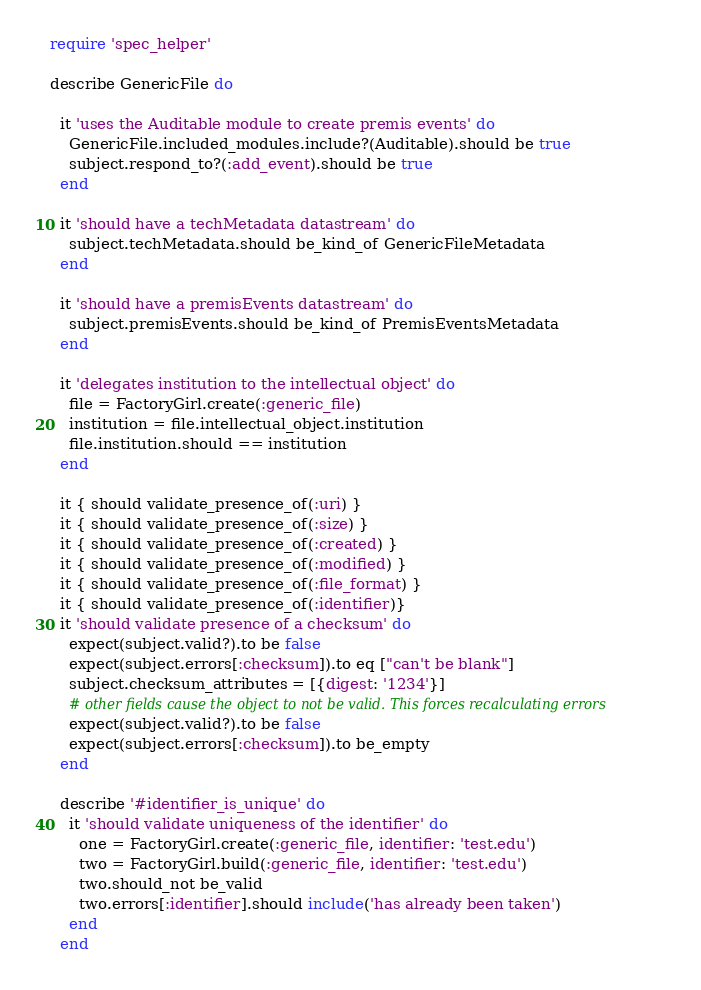<code> <loc_0><loc_0><loc_500><loc_500><_Ruby_>require 'spec_helper'

describe GenericFile do

  it 'uses the Auditable module to create premis events' do
    GenericFile.included_modules.include?(Auditable).should be true
    subject.respond_to?(:add_event).should be true
  end

  it 'should have a techMetadata datastream' do
    subject.techMetadata.should be_kind_of GenericFileMetadata
  end

  it 'should have a premisEvents datastream' do
    subject.premisEvents.should be_kind_of PremisEventsMetadata
  end

  it 'delegates institution to the intellectual object' do
    file = FactoryGirl.create(:generic_file)
    institution = file.intellectual_object.institution
    file.institution.should == institution
  end

  it { should validate_presence_of(:uri) }
  it { should validate_presence_of(:size) }
  it { should validate_presence_of(:created) }
  it { should validate_presence_of(:modified) }
  it { should validate_presence_of(:file_format) }
  it { should validate_presence_of(:identifier)}
  it 'should validate presence of a checksum' do
    expect(subject.valid?).to be false
    expect(subject.errors[:checksum]).to eq ["can't be blank"]
    subject.checksum_attributes = [{digest: '1234'}]
    # other fields cause the object to not be valid. This forces recalculating errors
    expect(subject.valid?).to be false
    expect(subject.errors[:checksum]).to be_empty
  end

  describe '#identifier_is_unique' do
    it 'should validate uniqueness of the identifier' do
      one = FactoryGirl.create(:generic_file, identifier: 'test.edu')
      two = FactoryGirl.build(:generic_file, identifier: 'test.edu')
      two.should_not be_valid
      two.errors[:identifier].should include('has already been taken')
    end
  end
</code> 